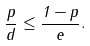<formula> <loc_0><loc_0><loc_500><loc_500>\frac { p } { d } \leq \frac { 1 - p } { e } .</formula> 